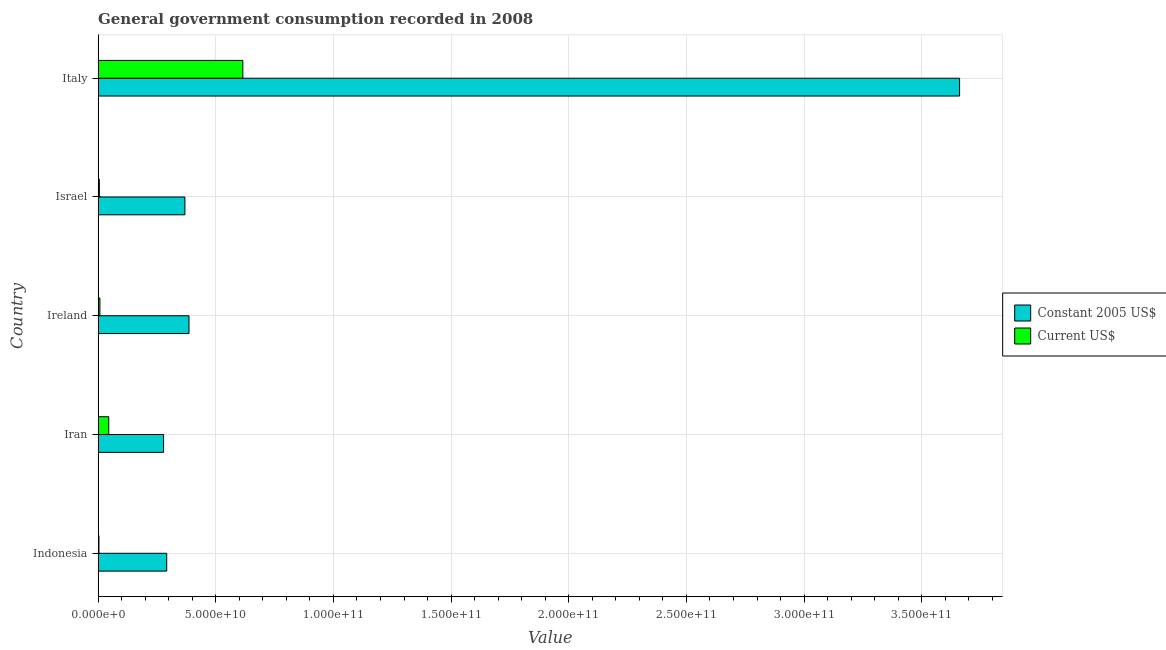How many different coloured bars are there?
Ensure brevity in your answer.  2. How many bars are there on the 3rd tick from the top?
Offer a very short reply. 2. In how many cases, is the number of bars for a given country not equal to the number of legend labels?
Ensure brevity in your answer.  0. What is the value consumed in current us$ in Ireland?
Keep it short and to the point. 7.61e+08. Across all countries, what is the maximum value consumed in constant 2005 us$?
Provide a succinct answer. 3.66e+11. Across all countries, what is the minimum value consumed in current us$?
Give a very brief answer. 3.64e+08. In which country was the value consumed in current us$ maximum?
Offer a very short reply. Italy. In which country was the value consumed in current us$ minimum?
Keep it short and to the point. Indonesia. What is the total value consumed in constant 2005 us$ in the graph?
Ensure brevity in your answer.  4.99e+11. What is the difference between the value consumed in current us$ in Indonesia and that in Iran?
Your answer should be compact. -4.15e+09. What is the difference between the value consumed in constant 2005 us$ in Iran and the value consumed in current us$ in Indonesia?
Your answer should be compact. 2.75e+1. What is the average value consumed in constant 2005 us$ per country?
Your answer should be very brief. 9.97e+1. What is the difference between the value consumed in current us$ and value consumed in constant 2005 us$ in Ireland?
Make the answer very short. -3.79e+1. What is the ratio of the value consumed in constant 2005 us$ in Iran to that in Israel?
Offer a terse response. 0.75. What is the difference between the highest and the second highest value consumed in current us$?
Offer a very short reply. 5.70e+1. What is the difference between the highest and the lowest value consumed in current us$?
Your response must be concise. 6.11e+1. Is the sum of the value consumed in constant 2005 us$ in Indonesia and Ireland greater than the maximum value consumed in current us$ across all countries?
Give a very brief answer. Yes. What does the 2nd bar from the top in Italy represents?
Offer a very short reply. Constant 2005 US$. What does the 2nd bar from the bottom in Iran represents?
Offer a very short reply. Current US$. Are all the bars in the graph horizontal?
Provide a succinct answer. Yes. How many countries are there in the graph?
Your answer should be very brief. 5. Where does the legend appear in the graph?
Offer a terse response. Center right. What is the title of the graph?
Keep it short and to the point. General government consumption recorded in 2008. Does "Female population" appear as one of the legend labels in the graph?
Provide a succinct answer. No. What is the label or title of the X-axis?
Your answer should be very brief. Value. What is the Value of Constant 2005 US$ in Indonesia?
Make the answer very short. 2.92e+1. What is the Value of Current US$ in Indonesia?
Keep it short and to the point. 3.64e+08. What is the Value of Constant 2005 US$ in Iran?
Give a very brief answer. 2.78e+1. What is the Value in Current US$ in Iran?
Keep it short and to the point. 4.51e+09. What is the Value of Constant 2005 US$ in Ireland?
Provide a succinct answer. 3.86e+1. What is the Value of Current US$ in Ireland?
Provide a succinct answer. 7.61e+08. What is the Value in Constant 2005 US$ in Israel?
Your answer should be compact. 3.69e+1. What is the Value of Current US$ in Israel?
Give a very brief answer. 5.30e+08. What is the Value in Constant 2005 US$ in Italy?
Keep it short and to the point. 3.66e+11. What is the Value in Current US$ in Italy?
Your answer should be compact. 6.15e+1. Across all countries, what is the maximum Value in Constant 2005 US$?
Make the answer very short. 3.66e+11. Across all countries, what is the maximum Value in Current US$?
Your answer should be compact. 6.15e+1. Across all countries, what is the minimum Value of Constant 2005 US$?
Offer a terse response. 2.78e+1. Across all countries, what is the minimum Value in Current US$?
Make the answer very short. 3.64e+08. What is the total Value in Constant 2005 US$ in the graph?
Your answer should be very brief. 4.99e+11. What is the total Value of Current US$ in the graph?
Your answer should be very brief. 6.77e+1. What is the difference between the Value of Constant 2005 US$ in Indonesia and that in Iran?
Your answer should be compact. 1.34e+09. What is the difference between the Value of Current US$ in Indonesia and that in Iran?
Make the answer very short. -4.15e+09. What is the difference between the Value in Constant 2005 US$ in Indonesia and that in Ireland?
Offer a very short reply. -9.46e+09. What is the difference between the Value in Current US$ in Indonesia and that in Ireland?
Your response must be concise. -3.97e+08. What is the difference between the Value in Constant 2005 US$ in Indonesia and that in Israel?
Provide a succinct answer. -7.73e+09. What is the difference between the Value of Current US$ in Indonesia and that in Israel?
Keep it short and to the point. -1.66e+08. What is the difference between the Value of Constant 2005 US$ in Indonesia and that in Italy?
Ensure brevity in your answer.  -3.37e+11. What is the difference between the Value in Current US$ in Indonesia and that in Italy?
Ensure brevity in your answer.  -6.11e+1. What is the difference between the Value in Constant 2005 US$ in Iran and that in Ireland?
Provide a succinct answer. -1.08e+1. What is the difference between the Value of Current US$ in Iran and that in Ireland?
Your response must be concise. 3.75e+09. What is the difference between the Value in Constant 2005 US$ in Iran and that in Israel?
Offer a very short reply. -9.06e+09. What is the difference between the Value of Current US$ in Iran and that in Israel?
Your answer should be compact. 3.98e+09. What is the difference between the Value of Constant 2005 US$ in Iran and that in Italy?
Give a very brief answer. -3.38e+11. What is the difference between the Value in Current US$ in Iran and that in Italy?
Make the answer very short. -5.70e+1. What is the difference between the Value in Constant 2005 US$ in Ireland and that in Israel?
Your answer should be very brief. 1.74e+09. What is the difference between the Value of Current US$ in Ireland and that in Israel?
Give a very brief answer. 2.31e+08. What is the difference between the Value in Constant 2005 US$ in Ireland and that in Italy?
Your response must be concise. -3.27e+11. What is the difference between the Value of Current US$ in Ireland and that in Italy?
Your response must be concise. -6.07e+1. What is the difference between the Value of Constant 2005 US$ in Israel and that in Italy?
Provide a succinct answer. -3.29e+11. What is the difference between the Value in Current US$ in Israel and that in Italy?
Ensure brevity in your answer.  -6.10e+1. What is the difference between the Value in Constant 2005 US$ in Indonesia and the Value in Current US$ in Iran?
Give a very brief answer. 2.46e+1. What is the difference between the Value of Constant 2005 US$ in Indonesia and the Value of Current US$ in Ireland?
Provide a succinct answer. 2.84e+1. What is the difference between the Value in Constant 2005 US$ in Indonesia and the Value in Current US$ in Israel?
Offer a terse response. 2.86e+1. What is the difference between the Value of Constant 2005 US$ in Indonesia and the Value of Current US$ in Italy?
Your answer should be compact. -3.23e+1. What is the difference between the Value in Constant 2005 US$ in Iran and the Value in Current US$ in Ireland?
Keep it short and to the point. 2.71e+1. What is the difference between the Value of Constant 2005 US$ in Iran and the Value of Current US$ in Israel?
Offer a very short reply. 2.73e+1. What is the difference between the Value in Constant 2005 US$ in Iran and the Value in Current US$ in Italy?
Your response must be concise. -3.37e+1. What is the difference between the Value in Constant 2005 US$ in Ireland and the Value in Current US$ in Israel?
Offer a terse response. 3.81e+1. What is the difference between the Value in Constant 2005 US$ in Ireland and the Value in Current US$ in Italy?
Your response must be concise. -2.29e+1. What is the difference between the Value in Constant 2005 US$ in Israel and the Value in Current US$ in Italy?
Give a very brief answer. -2.46e+1. What is the average Value of Constant 2005 US$ per country?
Make the answer very short. 9.97e+1. What is the average Value in Current US$ per country?
Make the answer very short. 1.35e+1. What is the difference between the Value of Constant 2005 US$ and Value of Current US$ in Indonesia?
Provide a short and direct response. 2.88e+1. What is the difference between the Value in Constant 2005 US$ and Value in Current US$ in Iran?
Your response must be concise. 2.33e+1. What is the difference between the Value of Constant 2005 US$ and Value of Current US$ in Ireland?
Keep it short and to the point. 3.79e+1. What is the difference between the Value in Constant 2005 US$ and Value in Current US$ in Israel?
Give a very brief answer. 3.63e+1. What is the difference between the Value in Constant 2005 US$ and Value in Current US$ in Italy?
Ensure brevity in your answer.  3.05e+11. What is the ratio of the Value of Constant 2005 US$ in Indonesia to that in Iran?
Keep it short and to the point. 1.05. What is the ratio of the Value in Current US$ in Indonesia to that in Iran?
Ensure brevity in your answer.  0.08. What is the ratio of the Value of Constant 2005 US$ in Indonesia to that in Ireland?
Ensure brevity in your answer.  0.75. What is the ratio of the Value in Current US$ in Indonesia to that in Ireland?
Your answer should be very brief. 0.48. What is the ratio of the Value in Constant 2005 US$ in Indonesia to that in Israel?
Make the answer very short. 0.79. What is the ratio of the Value of Current US$ in Indonesia to that in Israel?
Ensure brevity in your answer.  0.69. What is the ratio of the Value of Constant 2005 US$ in Indonesia to that in Italy?
Offer a terse response. 0.08. What is the ratio of the Value of Current US$ in Indonesia to that in Italy?
Provide a short and direct response. 0.01. What is the ratio of the Value of Constant 2005 US$ in Iran to that in Ireland?
Ensure brevity in your answer.  0.72. What is the ratio of the Value of Current US$ in Iran to that in Ireland?
Offer a very short reply. 5.93. What is the ratio of the Value in Constant 2005 US$ in Iran to that in Israel?
Offer a terse response. 0.75. What is the ratio of the Value of Current US$ in Iran to that in Israel?
Provide a succinct answer. 8.51. What is the ratio of the Value in Constant 2005 US$ in Iran to that in Italy?
Your answer should be compact. 0.08. What is the ratio of the Value of Current US$ in Iran to that in Italy?
Your response must be concise. 0.07. What is the ratio of the Value of Constant 2005 US$ in Ireland to that in Israel?
Offer a terse response. 1.05. What is the ratio of the Value of Current US$ in Ireland to that in Israel?
Give a very brief answer. 1.44. What is the ratio of the Value in Constant 2005 US$ in Ireland to that in Italy?
Your answer should be very brief. 0.11. What is the ratio of the Value in Current US$ in Ireland to that in Italy?
Provide a short and direct response. 0.01. What is the ratio of the Value of Constant 2005 US$ in Israel to that in Italy?
Ensure brevity in your answer.  0.1. What is the ratio of the Value of Current US$ in Israel to that in Italy?
Provide a succinct answer. 0.01. What is the difference between the highest and the second highest Value in Constant 2005 US$?
Your answer should be very brief. 3.27e+11. What is the difference between the highest and the second highest Value in Current US$?
Your answer should be compact. 5.70e+1. What is the difference between the highest and the lowest Value of Constant 2005 US$?
Offer a very short reply. 3.38e+11. What is the difference between the highest and the lowest Value of Current US$?
Offer a very short reply. 6.11e+1. 